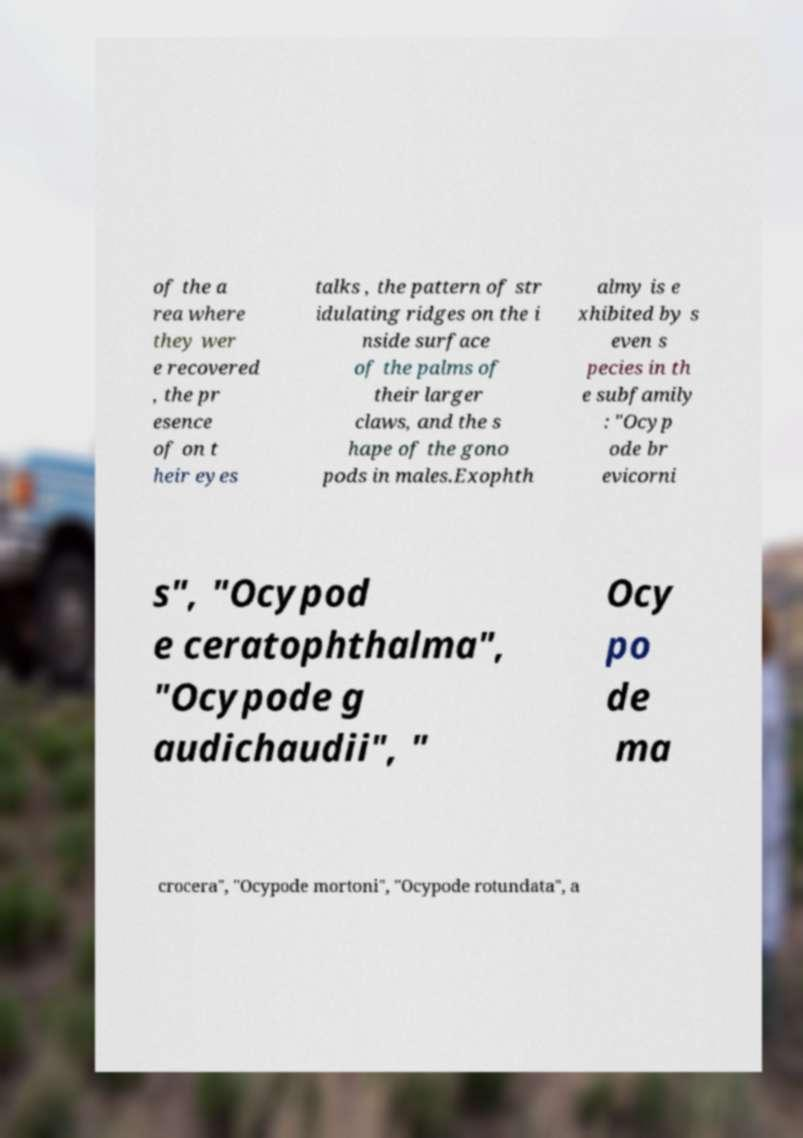I need the written content from this picture converted into text. Can you do that? of the a rea where they wer e recovered , the pr esence of on t heir eyes talks , the pattern of str idulating ridges on the i nside surface of the palms of their larger claws, and the s hape of the gono pods in males.Exophth almy is e xhibited by s even s pecies in th e subfamily : "Ocyp ode br evicorni s", "Ocypod e ceratophthalma", "Ocypode g audichaudii", " Ocy po de ma crocera", "Ocypode mortoni", "Ocypode rotundata", a 